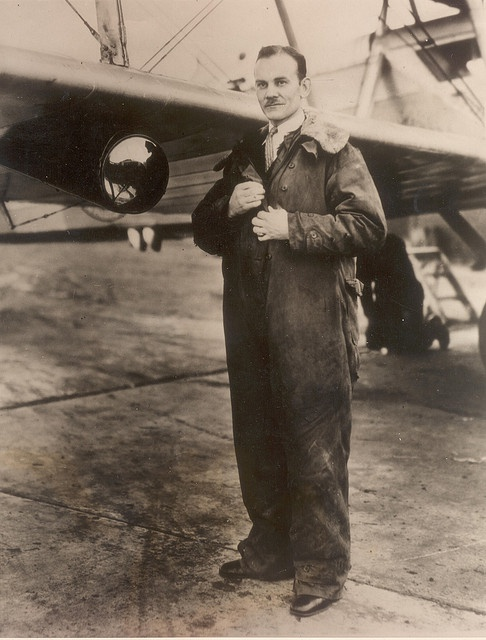Describe the objects in this image and their specific colors. I can see airplane in tan and black tones, people in tan, black, and gray tones, and people in tan, black, and gray tones in this image. 